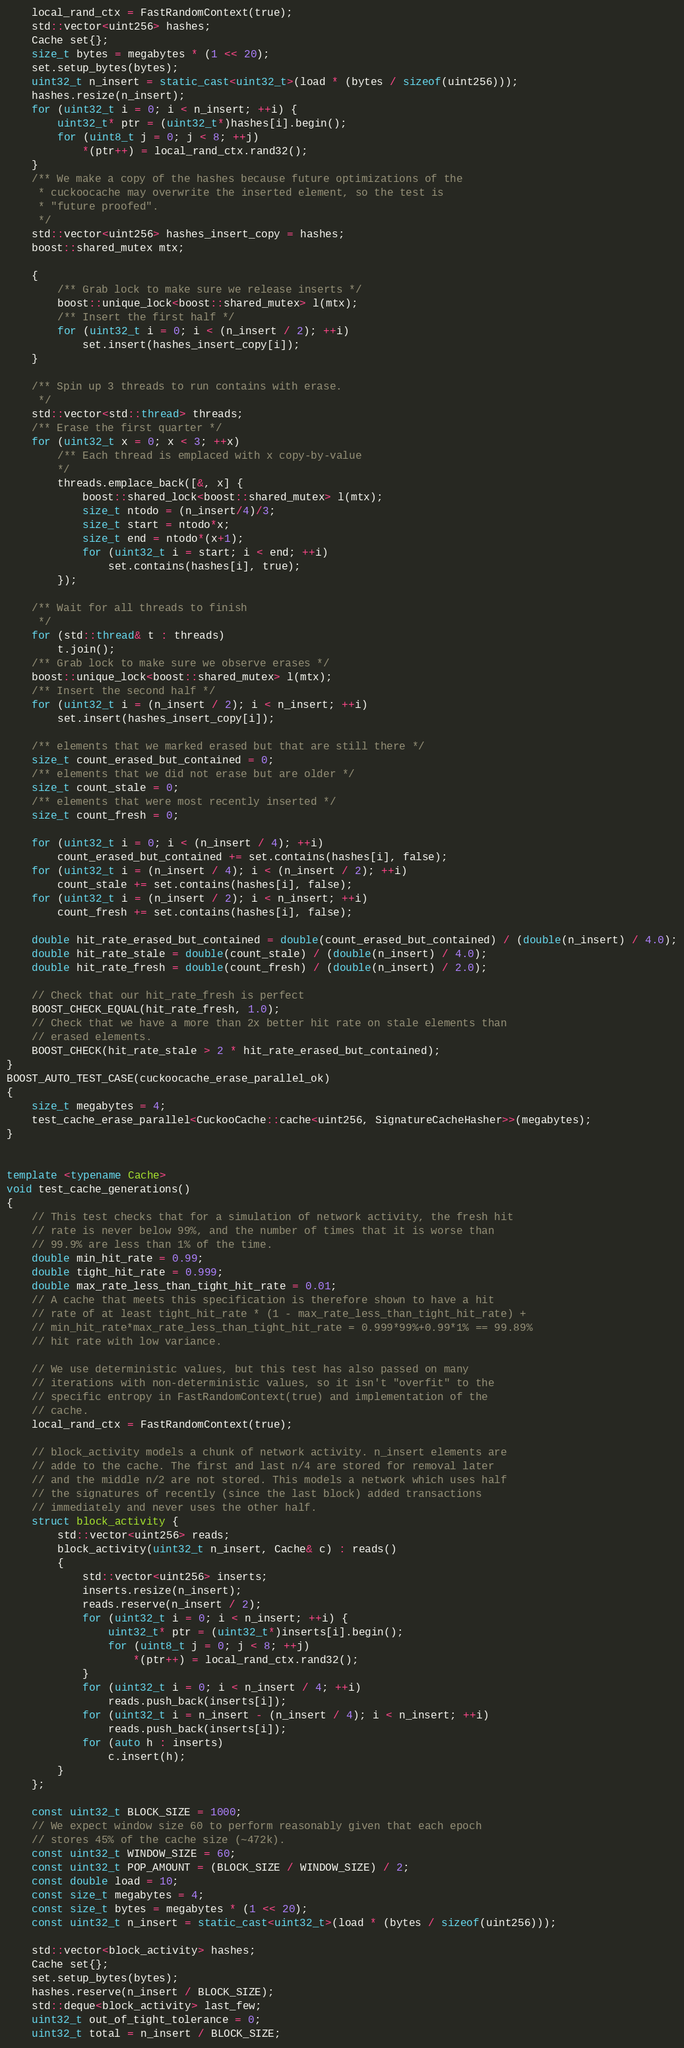Convert code to text. <code><loc_0><loc_0><loc_500><loc_500><_C++_>    local_rand_ctx = FastRandomContext(true);
    std::vector<uint256> hashes;
    Cache set{};
    size_t bytes = megabytes * (1 << 20);
    set.setup_bytes(bytes);
    uint32_t n_insert = static_cast<uint32_t>(load * (bytes / sizeof(uint256)));
    hashes.resize(n_insert);
    for (uint32_t i = 0; i < n_insert; ++i) {
        uint32_t* ptr = (uint32_t*)hashes[i].begin();
        for (uint8_t j = 0; j < 8; ++j)
            *(ptr++) = local_rand_ctx.rand32();
    }
    /** We make a copy of the hashes because future optimizations of the
     * cuckoocache may overwrite the inserted element, so the test is
     * "future proofed".
     */
    std::vector<uint256> hashes_insert_copy = hashes;
    boost::shared_mutex mtx;

    {
        /** Grab lock to make sure we release inserts */
        boost::unique_lock<boost::shared_mutex> l(mtx);
        /** Insert the first half */
        for (uint32_t i = 0; i < (n_insert / 2); ++i)
            set.insert(hashes_insert_copy[i]);
    }

    /** Spin up 3 threads to run contains with erase.
     */
    std::vector<std::thread> threads;
    /** Erase the first quarter */
    for (uint32_t x = 0; x < 3; ++x)
        /** Each thread is emplaced with x copy-by-value
        */
        threads.emplace_back([&, x] {
            boost::shared_lock<boost::shared_mutex> l(mtx);
            size_t ntodo = (n_insert/4)/3;
            size_t start = ntodo*x;
            size_t end = ntodo*(x+1);
            for (uint32_t i = start; i < end; ++i)
                set.contains(hashes[i], true);
        });

    /** Wait for all threads to finish
     */
    for (std::thread& t : threads)
        t.join();
    /** Grab lock to make sure we observe erases */
    boost::unique_lock<boost::shared_mutex> l(mtx);
    /** Insert the second half */
    for (uint32_t i = (n_insert / 2); i < n_insert; ++i)
        set.insert(hashes_insert_copy[i]);

    /** elements that we marked erased but that are still there */
    size_t count_erased_but_contained = 0;
    /** elements that we did not erase but are older */
    size_t count_stale = 0;
    /** elements that were most recently inserted */
    size_t count_fresh = 0;

    for (uint32_t i = 0; i < (n_insert / 4); ++i)
        count_erased_but_contained += set.contains(hashes[i], false);
    for (uint32_t i = (n_insert / 4); i < (n_insert / 2); ++i)
        count_stale += set.contains(hashes[i], false);
    for (uint32_t i = (n_insert / 2); i < n_insert; ++i)
        count_fresh += set.contains(hashes[i], false);

    double hit_rate_erased_but_contained = double(count_erased_but_contained) / (double(n_insert) / 4.0);
    double hit_rate_stale = double(count_stale) / (double(n_insert) / 4.0);
    double hit_rate_fresh = double(count_fresh) / (double(n_insert) / 2.0);

    // Check that our hit_rate_fresh is perfect
    BOOST_CHECK_EQUAL(hit_rate_fresh, 1.0);
    // Check that we have a more than 2x better hit rate on stale elements than
    // erased elements.
    BOOST_CHECK(hit_rate_stale > 2 * hit_rate_erased_but_contained);
}
BOOST_AUTO_TEST_CASE(cuckoocache_erase_parallel_ok)
{
    size_t megabytes = 4;
    test_cache_erase_parallel<CuckooCache::cache<uint256, SignatureCacheHasher>>(megabytes);
}


template <typename Cache>
void test_cache_generations()
{
    // This test checks that for a simulation of network activity, the fresh hit
    // rate is never below 99%, and the number of times that it is worse than
    // 99.9% are less than 1% of the time.
    double min_hit_rate = 0.99;
    double tight_hit_rate = 0.999;
    double max_rate_less_than_tight_hit_rate = 0.01;
    // A cache that meets this specification is therefore shown to have a hit
    // rate of at least tight_hit_rate * (1 - max_rate_less_than_tight_hit_rate) +
    // min_hit_rate*max_rate_less_than_tight_hit_rate = 0.999*99%+0.99*1% == 99.89%
    // hit rate with low variance.

    // We use deterministic values, but this test has also passed on many
    // iterations with non-deterministic values, so it isn't "overfit" to the
    // specific entropy in FastRandomContext(true) and implementation of the
    // cache.
    local_rand_ctx = FastRandomContext(true);

    // block_activity models a chunk of network activity. n_insert elements are
    // adde to the cache. The first and last n/4 are stored for removal later
    // and the middle n/2 are not stored. This models a network which uses half
    // the signatures of recently (since the last block) added transactions
    // immediately and never uses the other half.
    struct block_activity {
        std::vector<uint256> reads;
        block_activity(uint32_t n_insert, Cache& c) : reads()
        {
            std::vector<uint256> inserts;
            inserts.resize(n_insert);
            reads.reserve(n_insert / 2);
            for (uint32_t i = 0; i < n_insert; ++i) {
                uint32_t* ptr = (uint32_t*)inserts[i].begin();
                for (uint8_t j = 0; j < 8; ++j)
                    *(ptr++) = local_rand_ctx.rand32();
            }
            for (uint32_t i = 0; i < n_insert / 4; ++i)
                reads.push_back(inserts[i]);
            for (uint32_t i = n_insert - (n_insert / 4); i < n_insert; ++i)
                reads.push_back(inserts[i]);
            for (auto h : inserts)
                c.insert(h);
        }
    };

    const uint32_t BLOCK_SIZE = 1000;
    // We expect window size 60 to perform reasonably given that each epoch
    // stores 45% of the cache size (~472k).
    const uint32_t WINDOW_SIZE = 60;
    const uint32_t POP_AMOUNT = (BLOCK_SIZE / WINDOW_SIZE) / 2;
    const double load = 10;
    const size_t megabytes = 4;
    const size_t bytes = megabytes * (1 << 20);
    const uint32_t n_insert = static_cast<uint32_t>(load * (bytes / sizeof(uint256)));

    std::vector<block_activity> hashes;
    Cache set{};
    set.setup_bytes(bytes);
    hashes.reserve(n_insert / BLOCK_SIZE);
    std::deque<block_activity> last_few;
    uint32_t out_of_tight_tolerance = 0;
    uint32_t total = n_insert / BLOCK_SIZE;</code> 